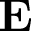Convert formula to latex. <formula><loc_0><loc_0><loc_500><loc_500>E</formula> 